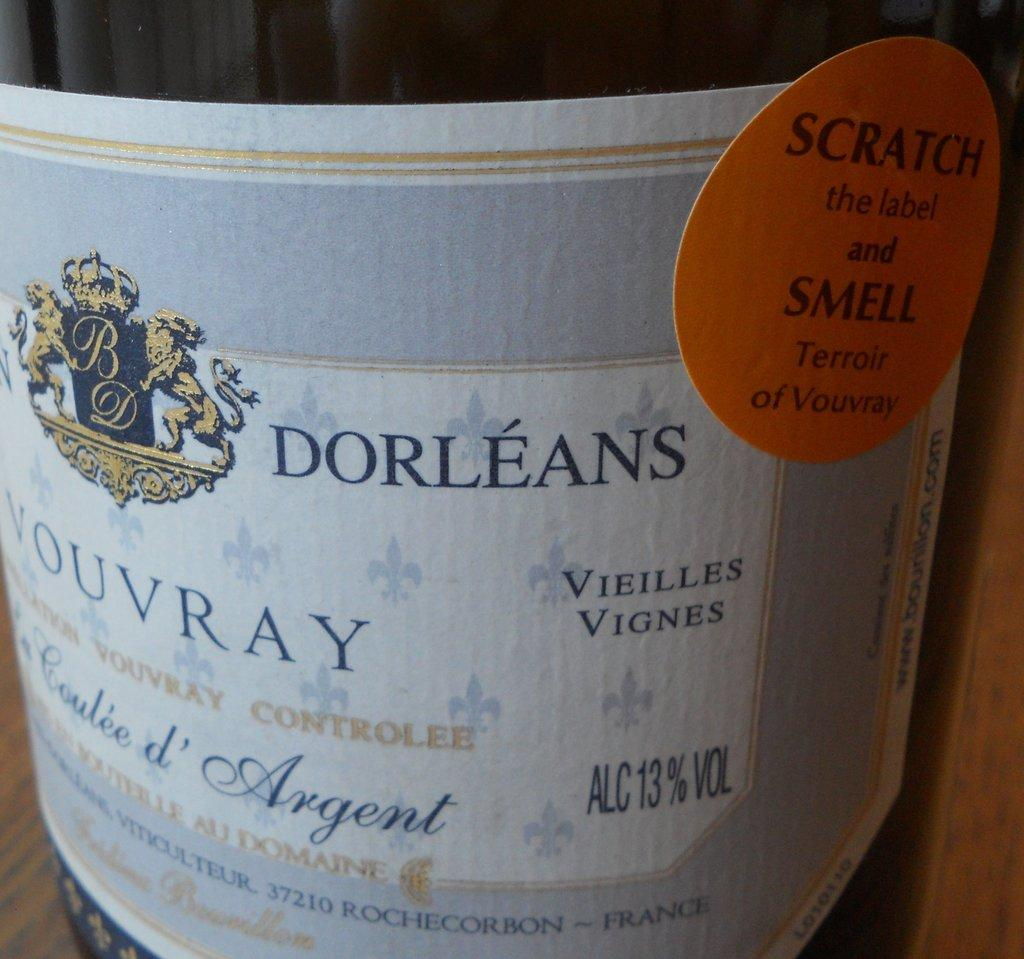What is the color of the main object in the image? The main object in the image is black. What can be found on the surface of the black object? The black object has labels on it. Is there any text visible on the object? Yes, there is text visible on the object. What type of cake is being served by the maid in the image? There is no maid or cake present in the image; it only features a black object with labels and text. 